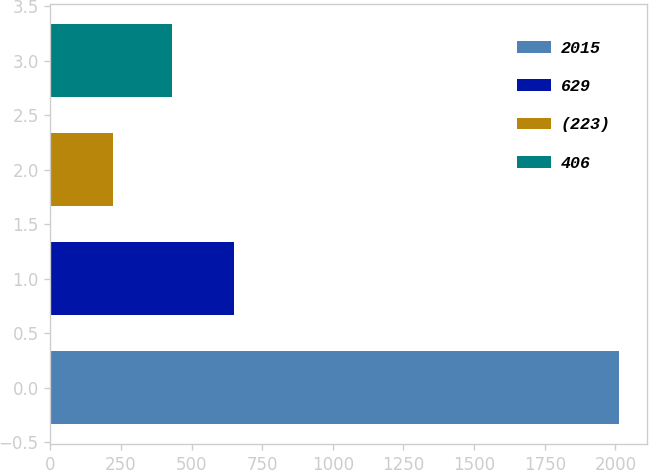<chart> <loc_0><loc_0><loc_500><loc_500><bar_chart><fcel>2015<fcel>629<fcel>(223)<fcel>406<nl><fcel>2013<fcel>650<fcel>220<fcel>430<nl></chart> 